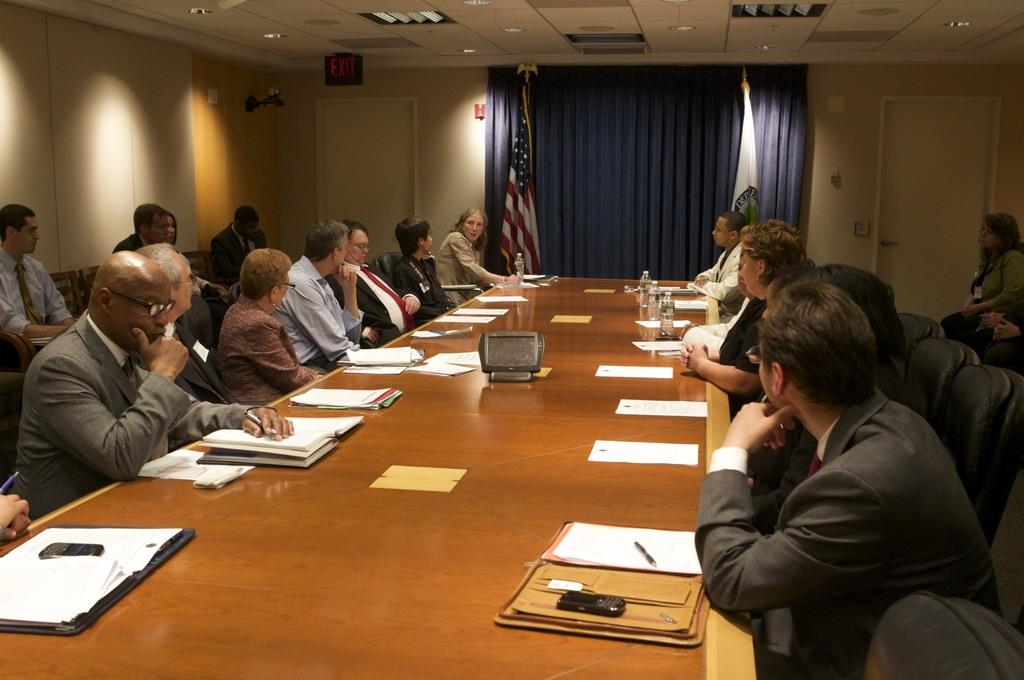What type of room is shown in the image? The image depicts a meeting room. What are the people in the room doing? People are seated on chairs in the room. What items can be seen on the table in the image? There are papers and water bottles on the table. What decorative elements are present in the room? There are two flags in the room and a curtain on the wall. What type of bone is visible on the table in the image? There is no bone present on the table in the image. Can you describe the wings of the bird in the image? There is no bird or wings visible in the image. 